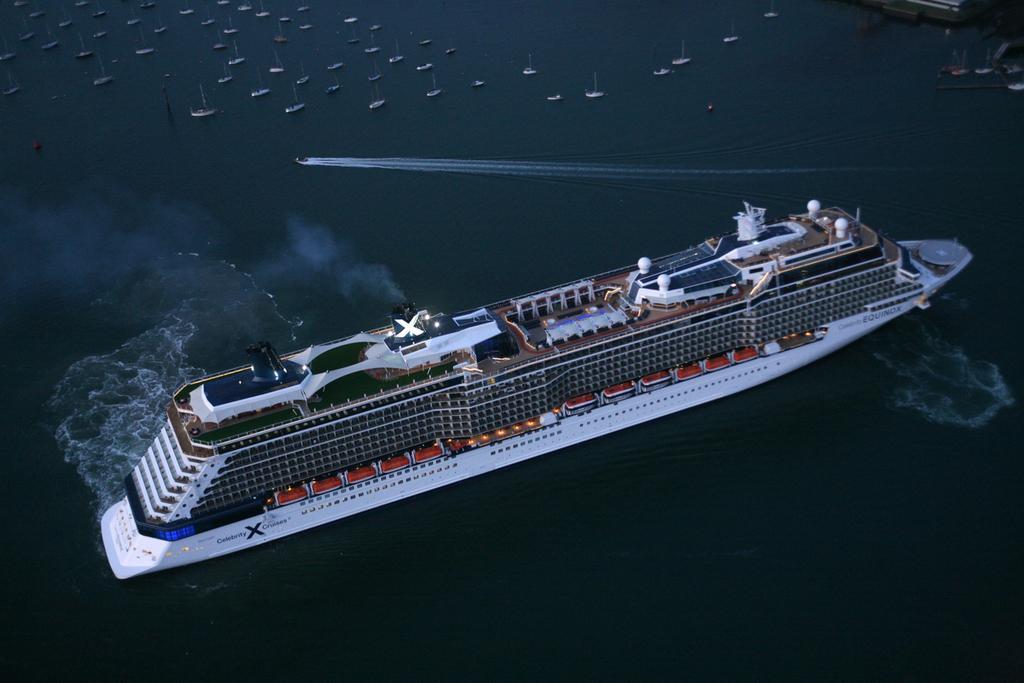Describe this image in one or two sentences. In this image a ship is sailing in the water. Top of image few boats are sailing in water. 